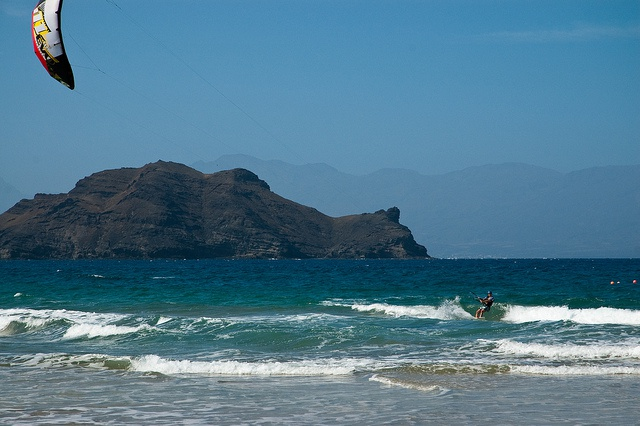Describe the objects in this image and their specific colors. I can see kite in teal, black, lightgray, darkgray, and gray tones, people in gray, black, and blue tones, and surfboard in teal, gray, darkgray, and black tones in this image. 